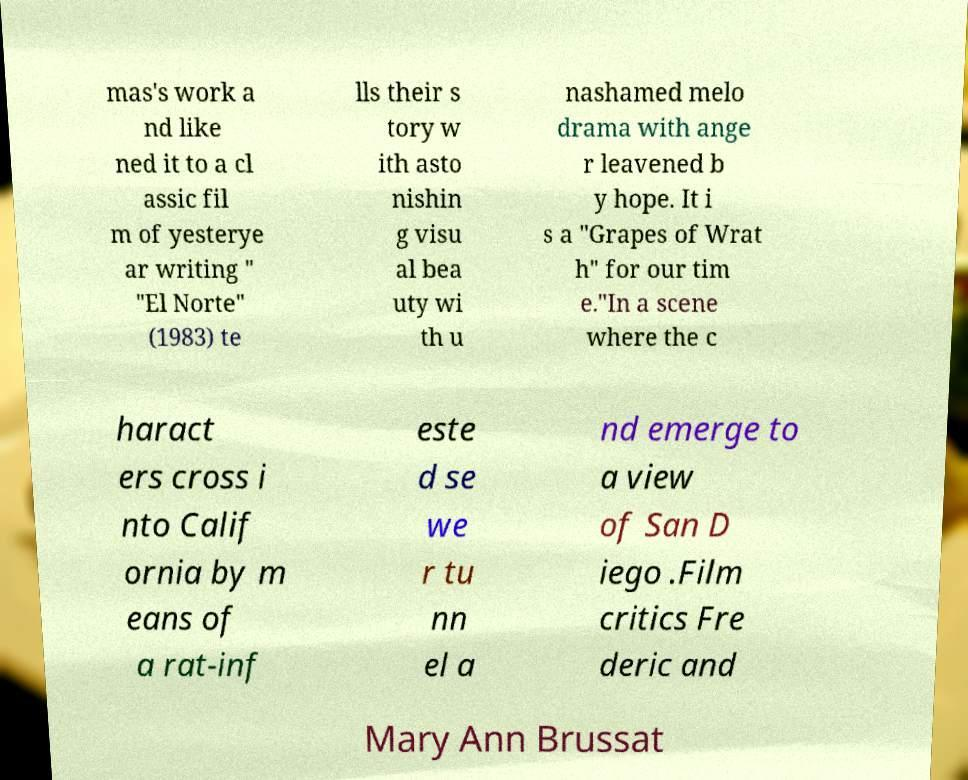Please read and relay the text visible in this image. What does it say? mas's work a nd like ned it to a cl assic fil m of yesterye ar writing " "El Norte" (1983) te lls their s tory w ith asto nishin g visu al bea uty wi th u nashamed melo drama with ange r leavened b y hope. It i s a "Grapes of Wrat h" for our tim e."In a scene where the c haract ers cross i nto Calif ornia by m eans of a rat-inf este d se we r tu nn el a nd emerge to a view of San D iego .Film critics Fre deric and Mary Ann Brussat 